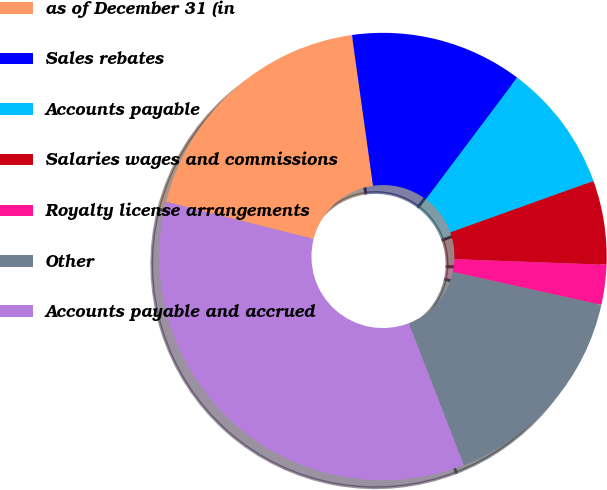Convert chart. <chart><loc_0><loc_0><loc_500><loc_500><pie_chart><fcel>as of December 31 (in<fcel>Sales rebates<fcel>Accounts payable<fcel>Salaries wages and commissions<fcel>Royalty license arrangements<fcel>Other<fcel>Accounts payable and accrued<nl><fcel>18.85%<fcel>12.46%<fcel>9.27%<fcel>6.07%<fcel>2.88%<fcel>15.65%<fcel>34.82%<nl></chart> 